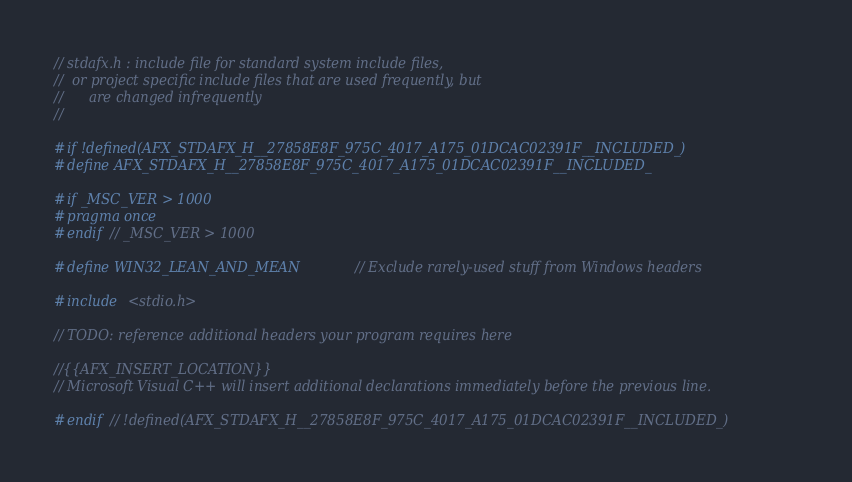Convert code to text. <code><loc_0><loc_0><loc_500><loc_500><_C_>// stdafx.h : include file for standard system include files,
//  or project specific include files that are used frequently, but
//      are changed infrequently
//

#if !defined(AFX_STDAFX_H__27858E8F_975C_4017_A175_01DCAC02391F__INCLUDED_)
#define AFX_STDAFX_H__27858E8F_975C_4017_A175_01DCAC02391F__INCLUDED_

#if _MSC_VER > 1000
#pragma once
#endif // _MSC_VER > 1000

#define WIN32_LEAN_AND_MEAN		// Exclude rarely-used stuff from Windows headers

#include <stdio.h>

// TODO: reference additional headers your program requires here

//{{AFX_INSERT_LOCATION}}
// Microsoft Visual C++ will insert additional declarations immediately before the previous line.

#endif // !defined(AFX_STDAFX_H__27858E8F_975C_4017_A175_01DCAC02391F__INCLUDED_)
</code> 